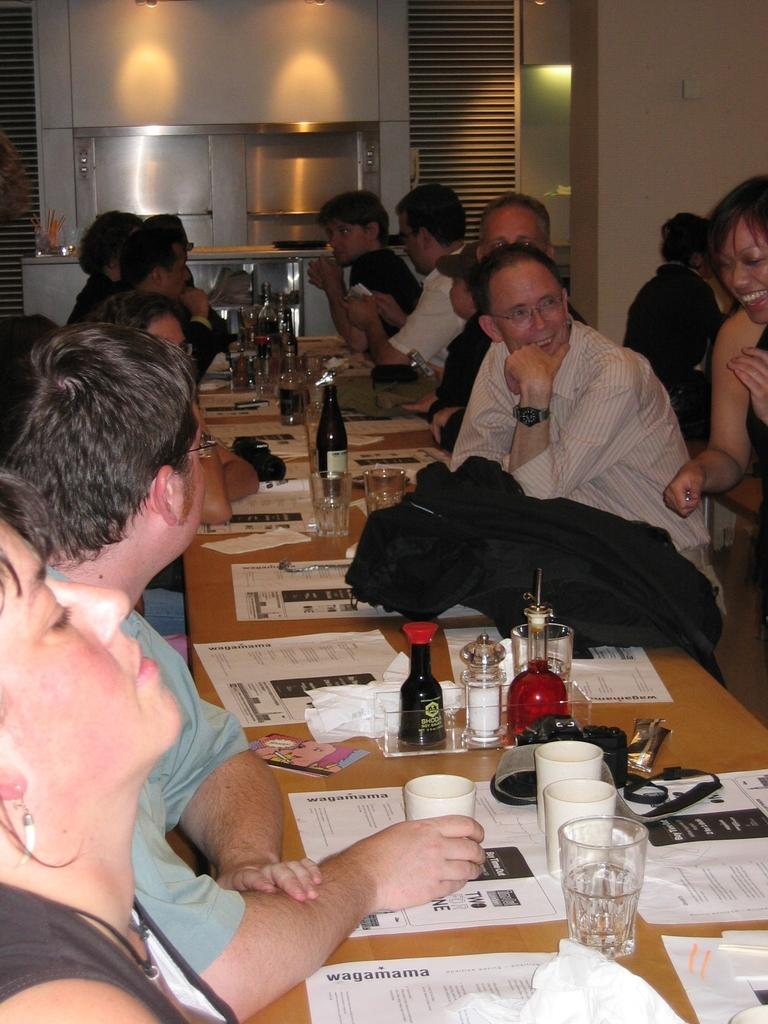Who is present in the image? There are people in the image. What are the people doing in the image? The people are sitting at a long table. What type of event is taking place in the image? The table is at a party. What type of action is the plough performing at the party in the image? There is no plough present in the image, and therefore no such action can be observed. 